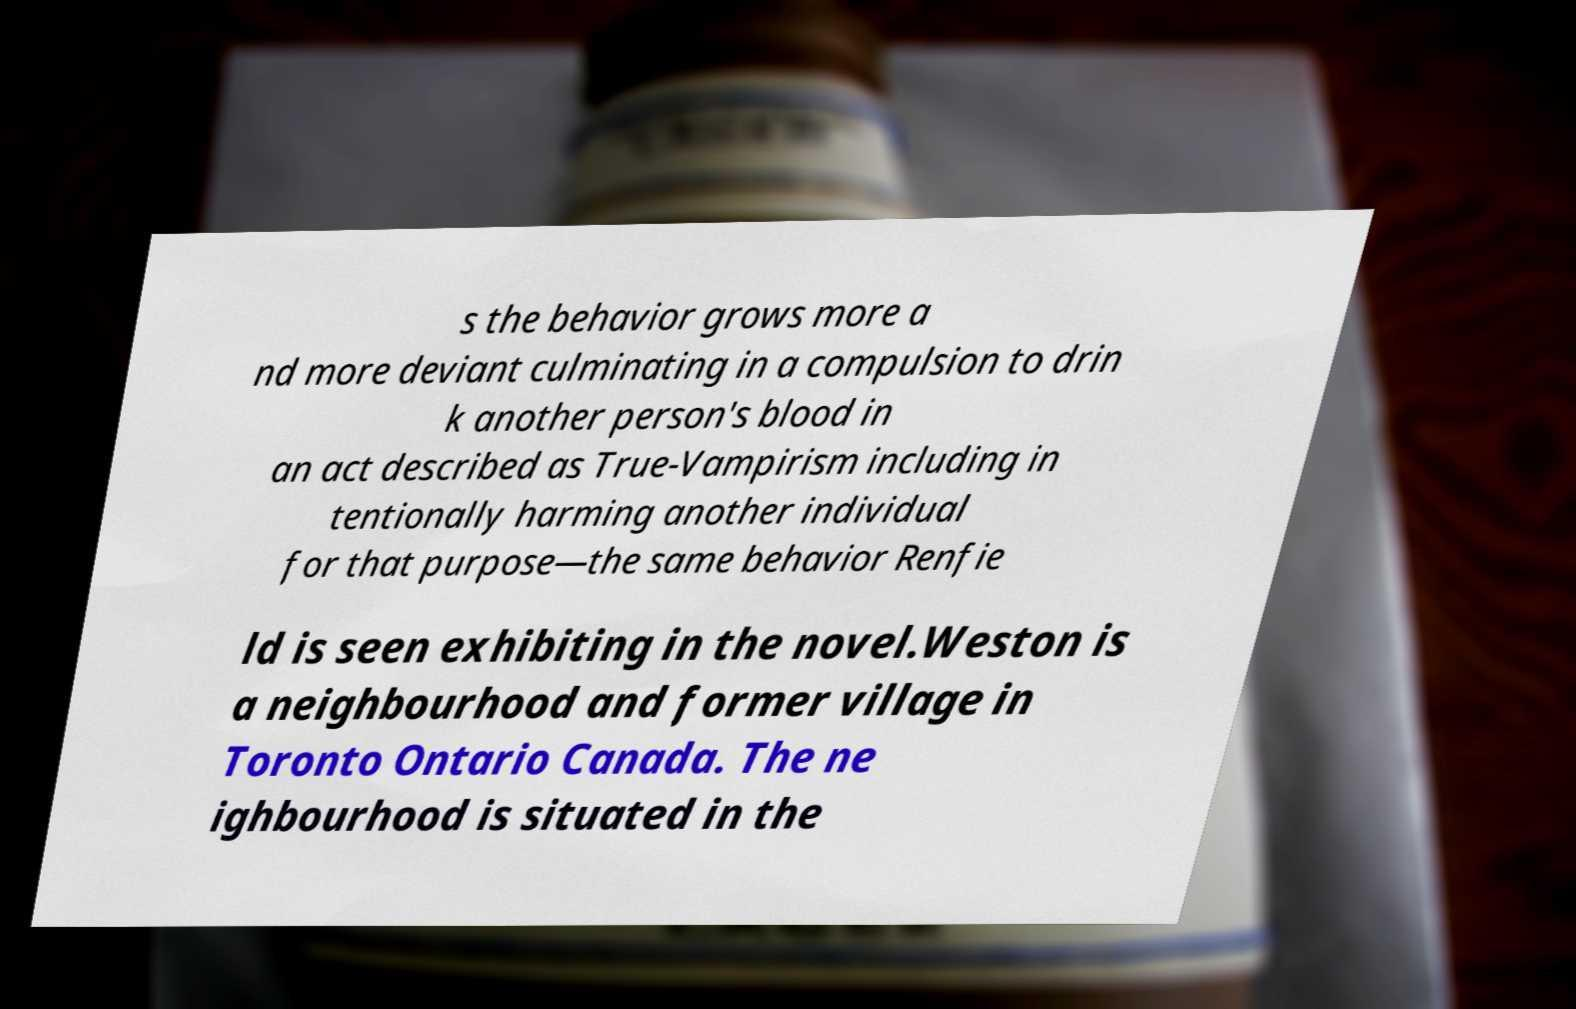There's text embedded in this image that I need extracted. Can you transcribe it verbatim? s the behavior grows more a nd more deviant culminating in a compulsion to drin k another person's blood in an act described as True-Vampirism including in tentionally harming another individual for that purpose—the same behavior Renfie ld is seen exhibiting in the novel.Weston is a neighbourhood and former village in Toronto Ontario Canada. The ne ighbourhood is situated in the 